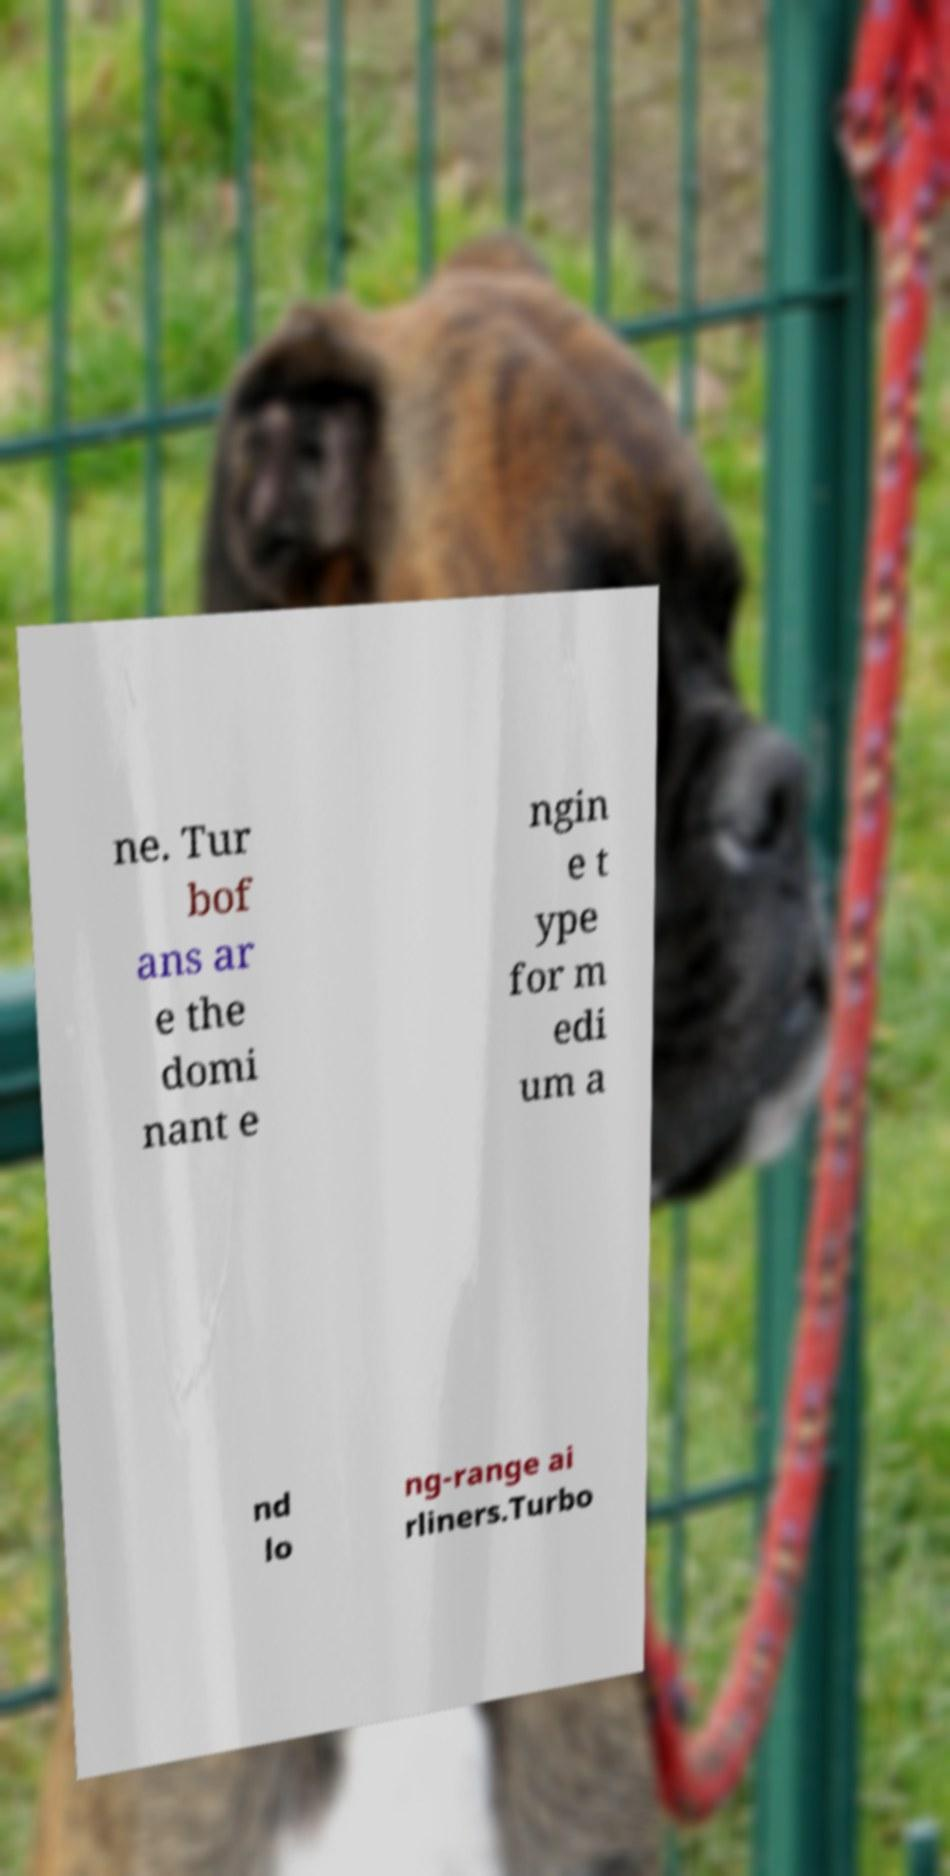I need the written content from this picture converted into text. Can you do that? ne. Tur bof ans ar e the domi nant e ngin e t ype for m edi um a nd lo ng-range ai rliners.Turbo 